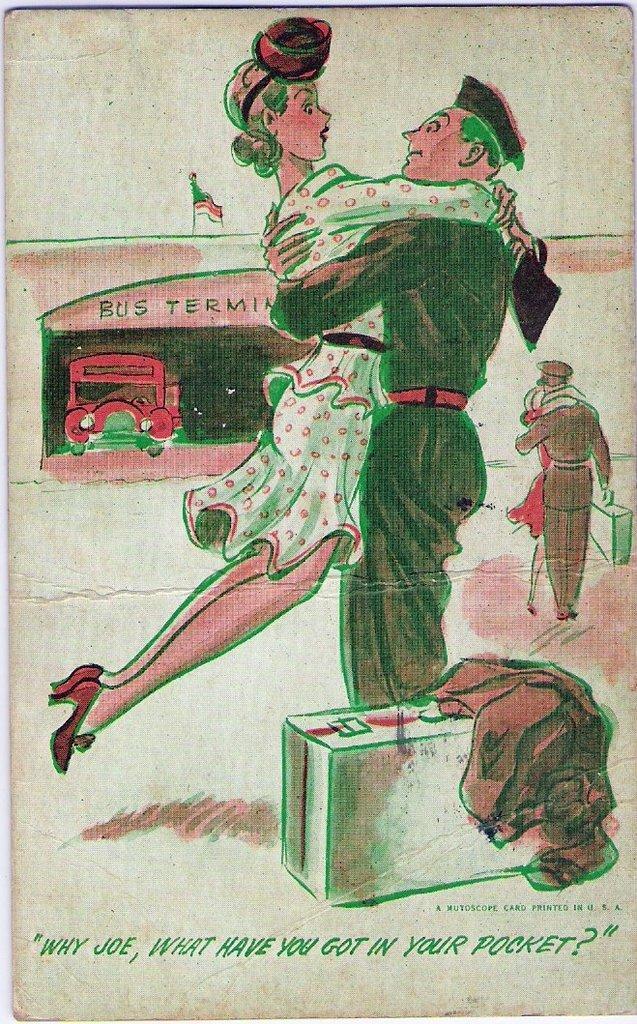How would you summarize this image in a sentence or two? In the picture I can see a painting in which we can see a man carrying a woman wearing white color dress. Here we can see a suitcase on the road. On the right side of the image we can see a man and a woman. In the background, we can see a red color vehicle at the bus terminal and we can see a flag. Here we can see some text on the bottom of the image. 